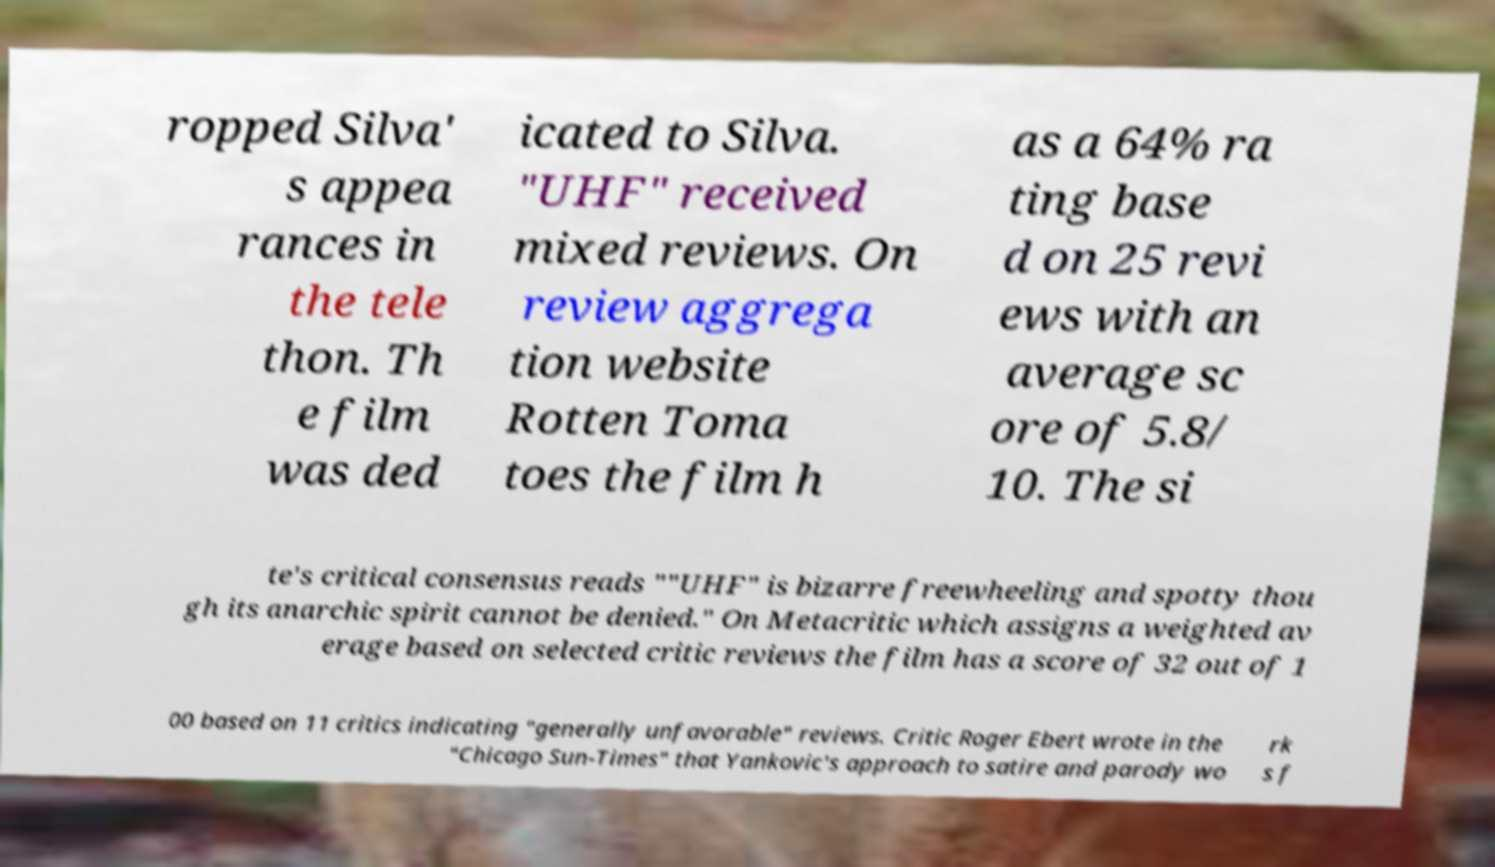Could you extract and type out the text from this image? ropped Silva' s appea rances in the tele thon. Th e film was ded icated to Silva. "UHF" received mixed reviews. On review aggrega tion website Rotten Toma toes the film h as a 64% ra ting base d on 25 revi ews with an average sc ore of 5.8/ 10. The si te's critical consensus reads ""UHF" is bizarre freewheeling and spotty thou gh its anarchic spirit cannot be denied." On Metacritic which assigns a weighted av erage based on selected critic reviews the film has a score of 32 out of 1 00 based on 11 critics indicating "generally unfavorable" reviews. Critic Roger Ebert wrote in the "Chicago Sun-Times" that Yankovic's approach to satire and parody wo rk s f 